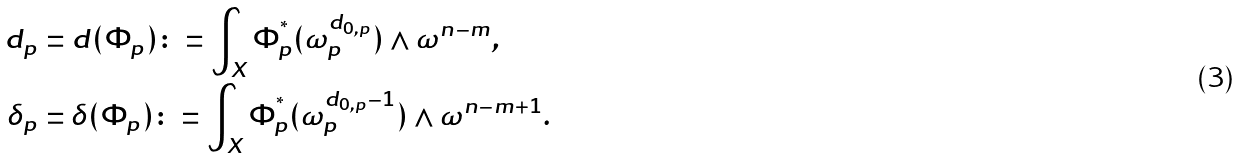Convert formula to latex. <formula><loc_0><loc_0><loc_500><loc_500>d _ { p } & = d ( \Phi _ { p } ) \colon = \int _ { X } \Phi _ { p } ^ { ^ { * } } ( \omega _ { p } ^ { d _ { 0 , p } } ) \wedge \omega ^ { n - m } , \\ \delta _ { p } & = \delta ( \Phi _ { p } ) \colon = \int _ { X } \Phi _ { p } ^ { ^ { * } } ( \omega _ { p } ^ { d _ { 0 , p } - 1 } ) \wedge \omega ^ { n - m + 1 } . \\</formula> 